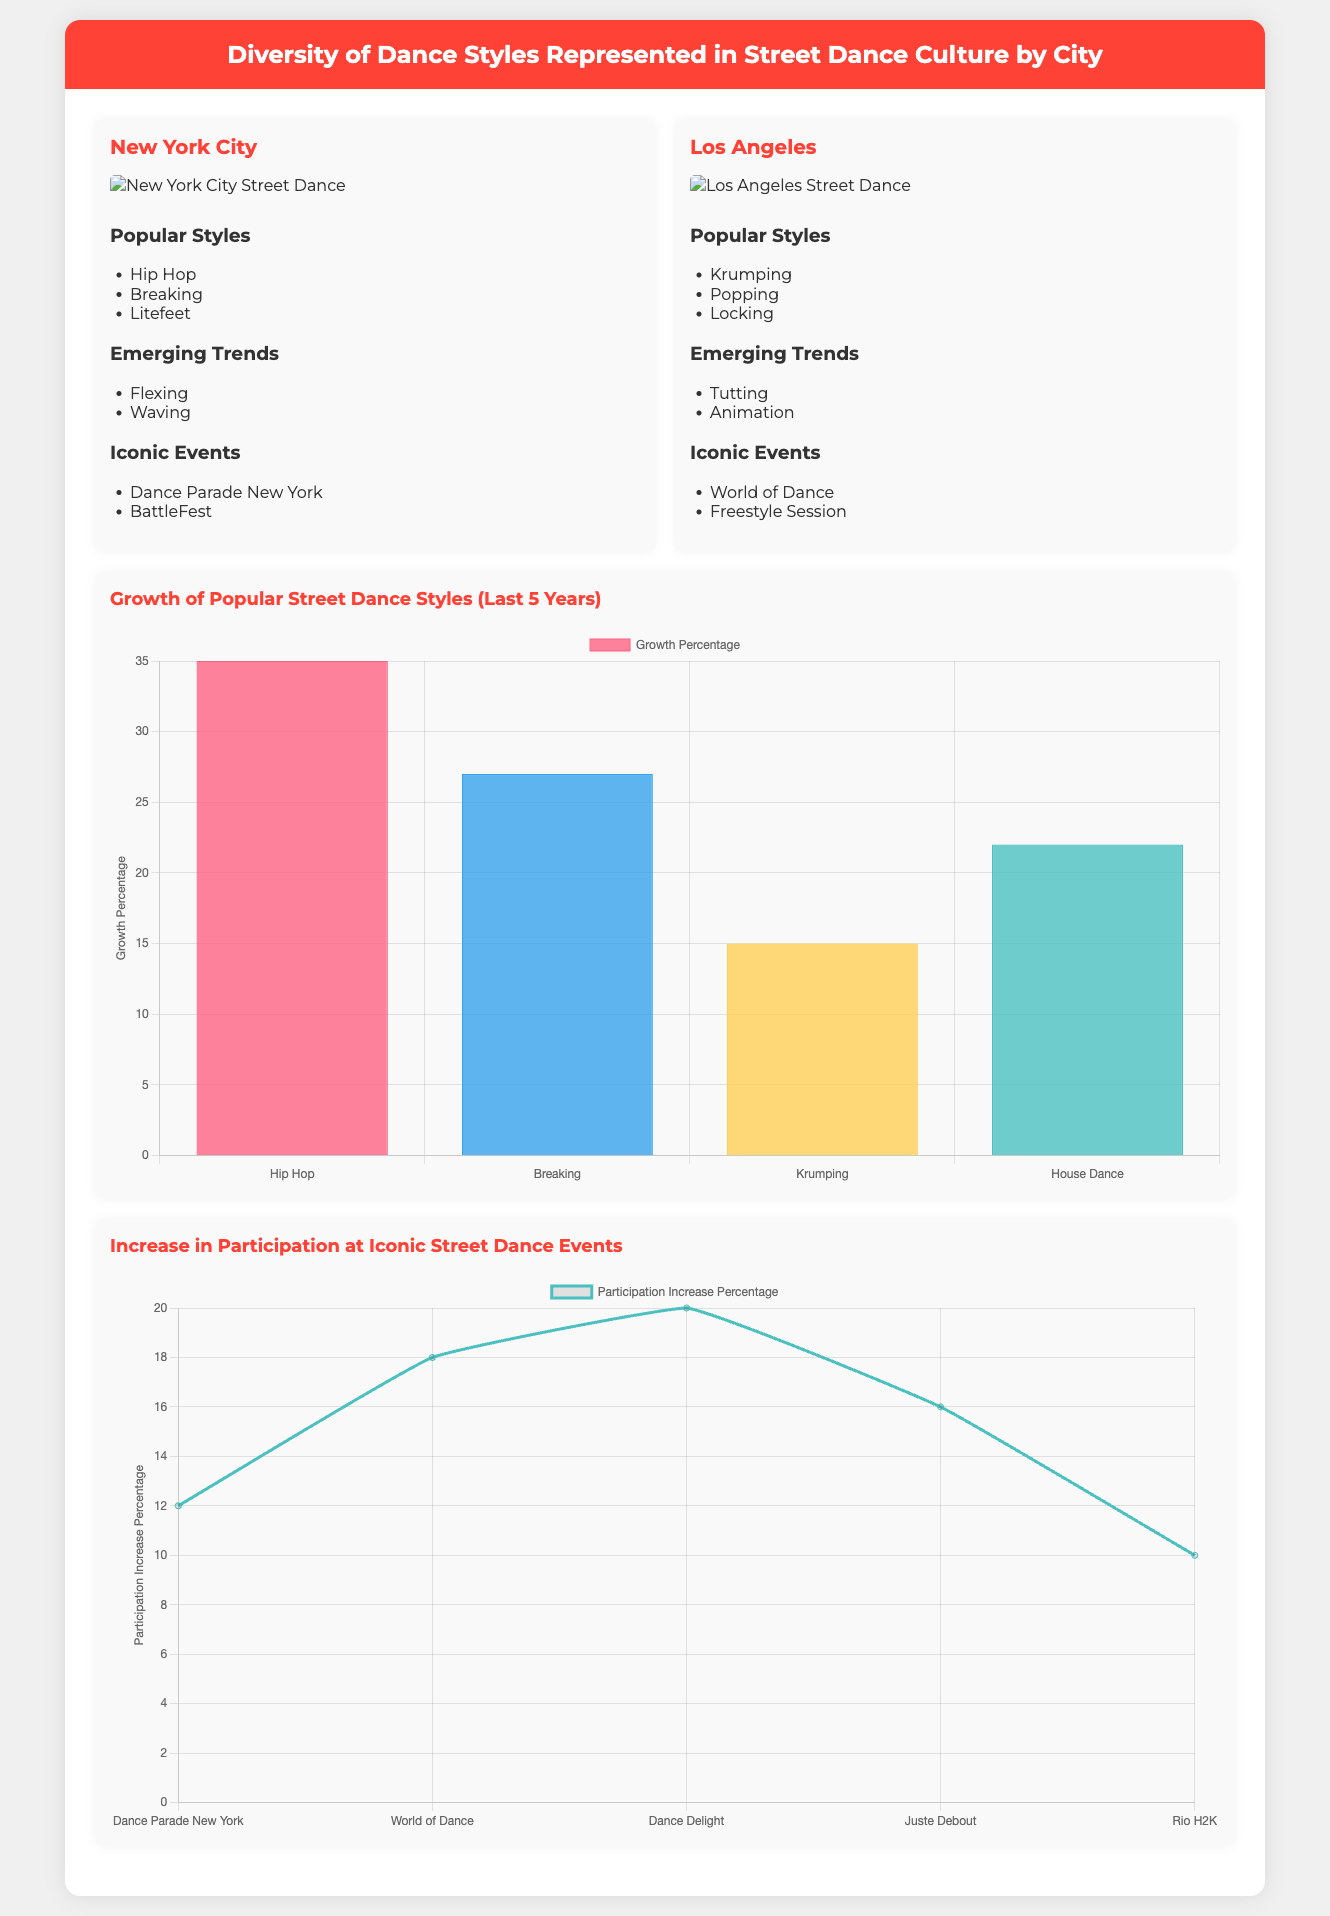What are the popular styles in New York City? The popular styles listed for New York City are Hip Hop, Breaking, and Litefeet.
Answer: Hip Hop, Breaking, Litefeet What is an emerging trend in Los Angeles? An emerging trend listed for Los Angeles is Tutting.
Answer: Tutting Which city features the event "Dance Parade New York"? The document states that "Dance Parade New York" is an iconic event in New York City.
Answer: New York City What style has the highest growth percentage? According to the bar chart, Hip Hop has the highest growth percentage at 35%.
Answer: 35% How many styles are mentioned for Los Angeles? The document lists three popular styles for Los Angeles: Krumping, Popping, Locking.
Answer: Three What is the participation increase percentage for "World of Dance"? The document states that the participation increase percentage for "World of Dance" is 18%.
Answer: 18% Which style shows the second highest growth percentage? In the bar chart, Breaking shows the second highest growth percentage at 27%.
Answer: 27% What is the total number of iconic events listed for New York City? The document lists two iconic events for New York City: Dance Parade New York and BattleFest.
Answer: Two 